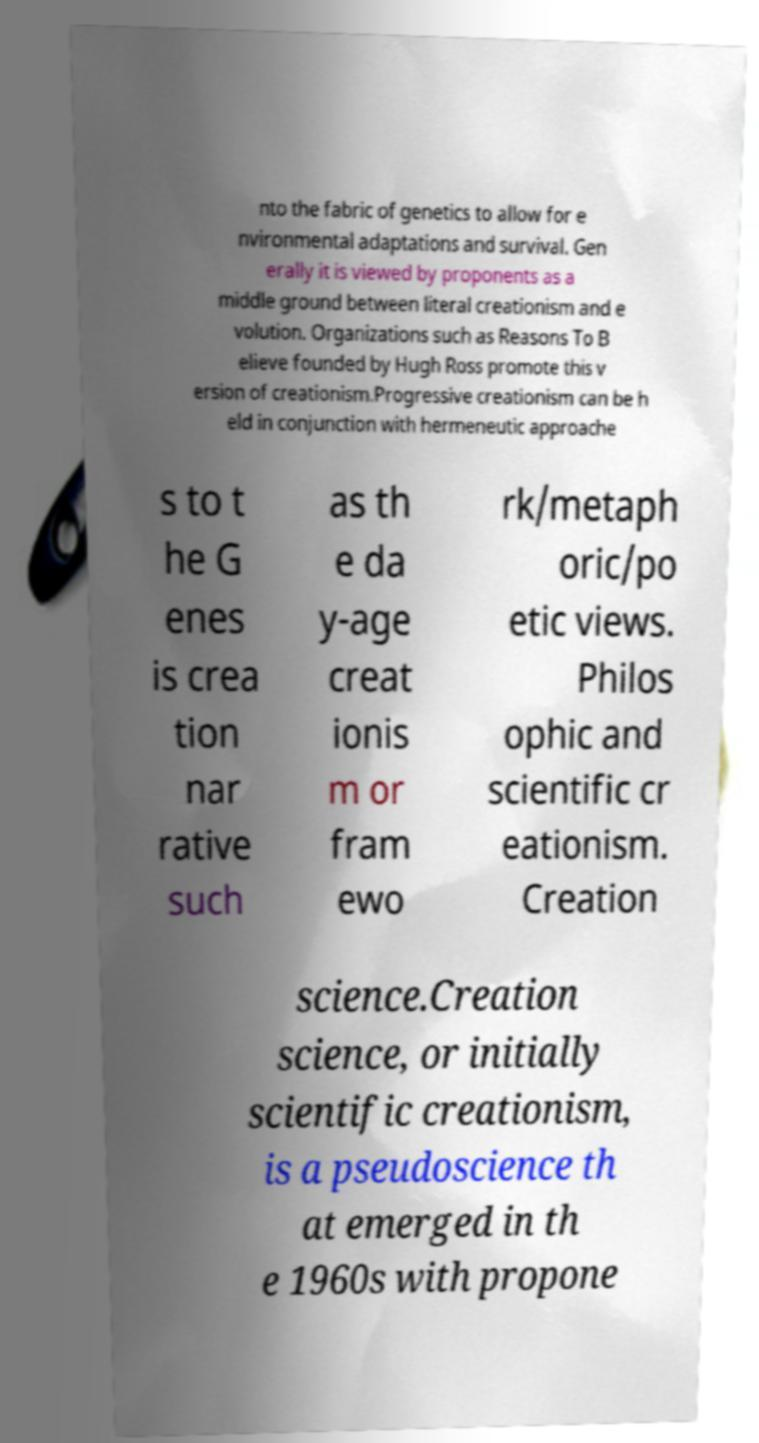Can you accurately transcribe the text from the provided image for me? nto the fabric of genetics to allow for e nvironmental adaptations and survival. Gen erally it is viewed by proponents as a middle ground between literal creationism and e volution. Organizations such as Reasons To B elieve founded by Hugh Ross promote this v ersion of creationism.Progressive creationism can be h eld in conjunction with hermeneutic approache s to t he G enes is crea tion nar rative such as th e da y-age creat ionis m or fram ewo rk/metaph oric/po etic views. Philos ophic and scientific cr eationism. Creation science.Creation science, or initially scientific creationism, is a pseudoscience th at emerged in th e 1960s with propone 